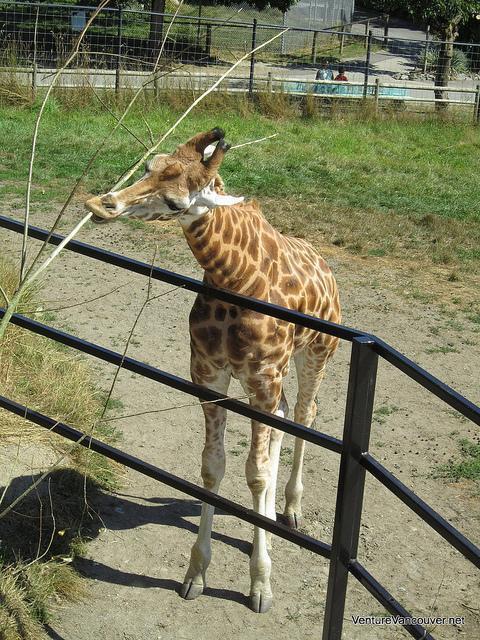How many skis are level against the snow?
Give a very brief answer. 0. 